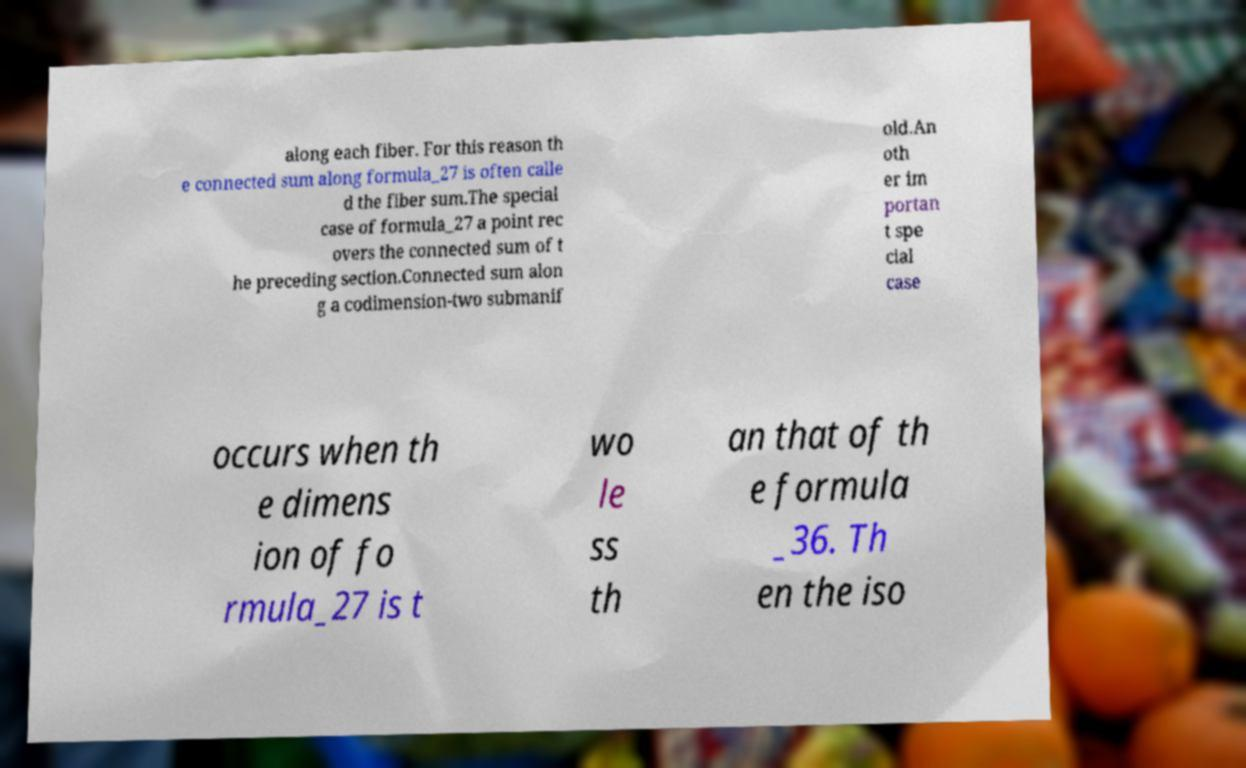What messages or text are displayed in this image? I need them in a readable, typed format. along each fiber. For this reason th e connected sum along formula_27 is often calle d the fiber sum.The special case of formula_27 a point rec overs the connected sum of t he preceding section.Connected sum alon g a codimension-two submanif old.An oth er im portan t spe cial case occurs when th e dimens ion of fo rmula_27 is t wo le ss th an that of th e formula _36. Th en the iso 